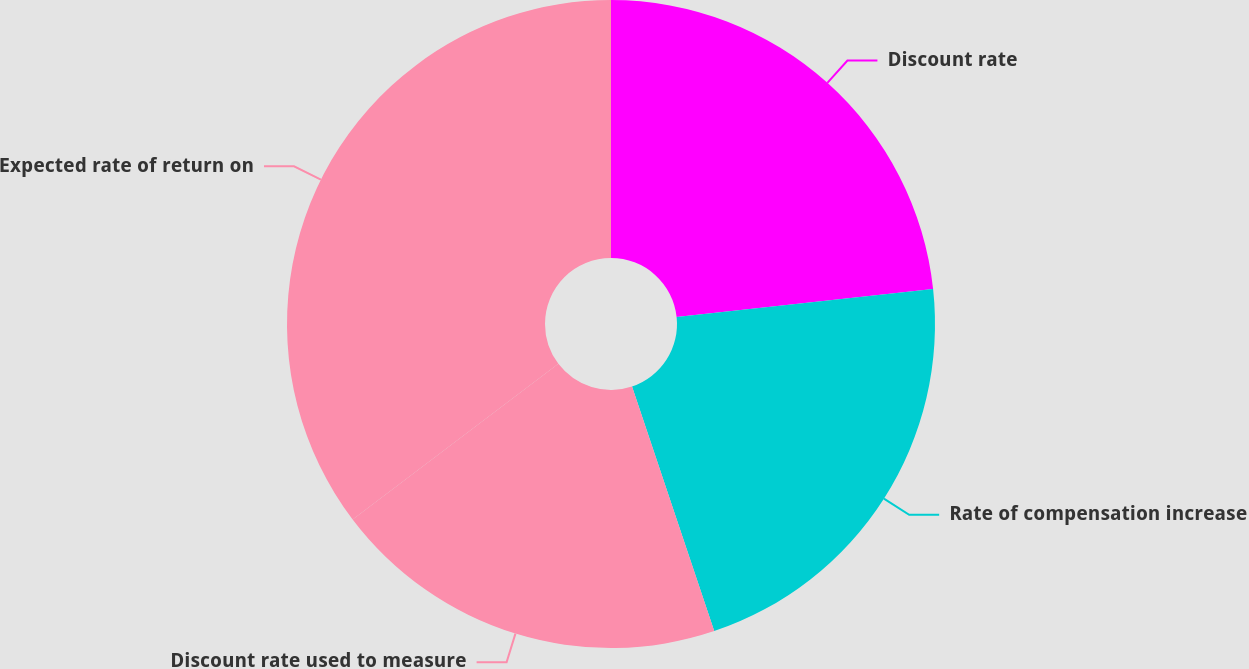Convert chart to OTSL. <chart><loc_0><loc_0><loc_500><loc_500><pie_chart><fcel>Discount rate<fcel>Rate of compensation increase<fcel>Discount rate used to measure<fcel>Expected rate of return on<nl><fcel>23.28%<fcel>21.56%<fcel>19.85%<fcel>35.31%<nl></chart> 